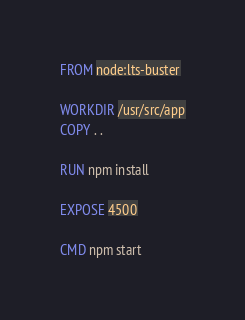<code> <loc_0><loc_0><loc_500><loc_500><_Dockerfile_>FROM node:lts-buster

WORKDIR /usr/src/app
COPY . .

RUN npm install

EXPOSE 4500

CMD npm start
</code> 